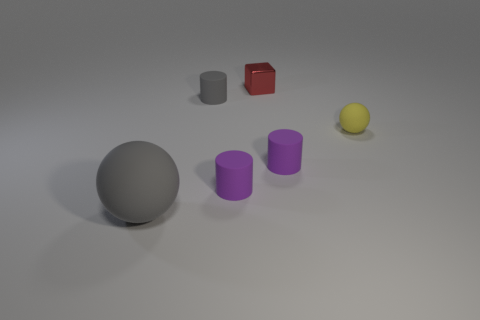Are there any other things that are made of the same material as the tiny cube?
Offer a terse response. No. What number of other things are the same shape as the big rubber object?
Give a very brief answer. 1. The rubber sphere that is behind the big object is what color?
Keep it short and to the point. Yellow. Is the red thing made of the same material as the tiny gray cylinder?
Your answer should be compact. No. How many things are purple matte objects or purple objects that are to the left of the red shiny thing?
Keep it short and to the point. 2. What is the size of the other thing that is the same color as the big thing?
Provide a succinct answer. Small. There is a gray rubber thing in front of the yellow matte sphere; what shape is it?
Ensure brevity in your answer.  Sphere. Does the matte cylinder behind the small yellow sphere have the same color as the large rubber thing?
Ensure brevity in your answer.  Yes. What material is the cylinder that is the same color as the big rubber thing?
Make the answer very short. Rubber. Does the gray thing right of the gray ball have the same size as the metal cube?
Your answer should be very brief. Yes. 